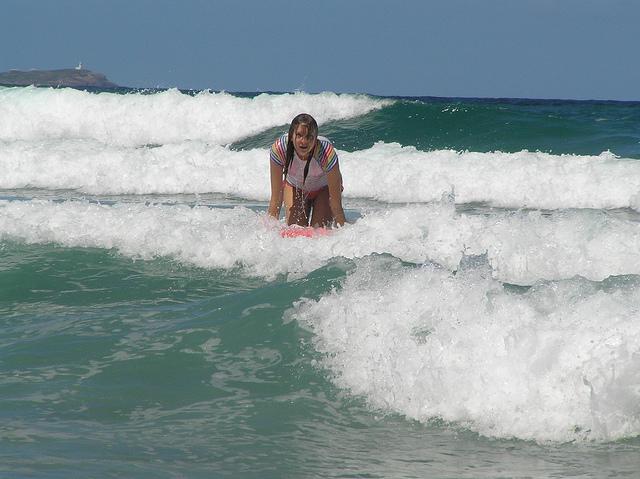Is she wearing a bathing suit?
Give a very brief answer. Yes. What kind of board is the girl kneeling on?
Be succinct. Surfboard. What is on the rock in the back?
Answer briefly. Lighthouse. 